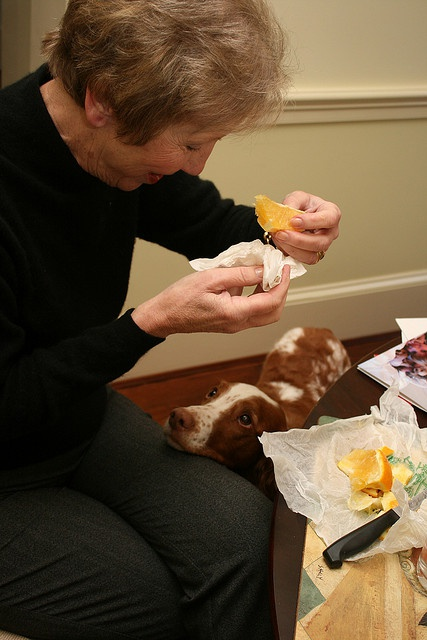Describe the objects in this image and their specific colors. I can see people in black, maroon, and gray tones, dining table in black and tan tones, dog in black, maroon, brown, and gray tones, orange in black, orange, khaki, and gold tones, and knife in black, gray, and tan tones in this image. 